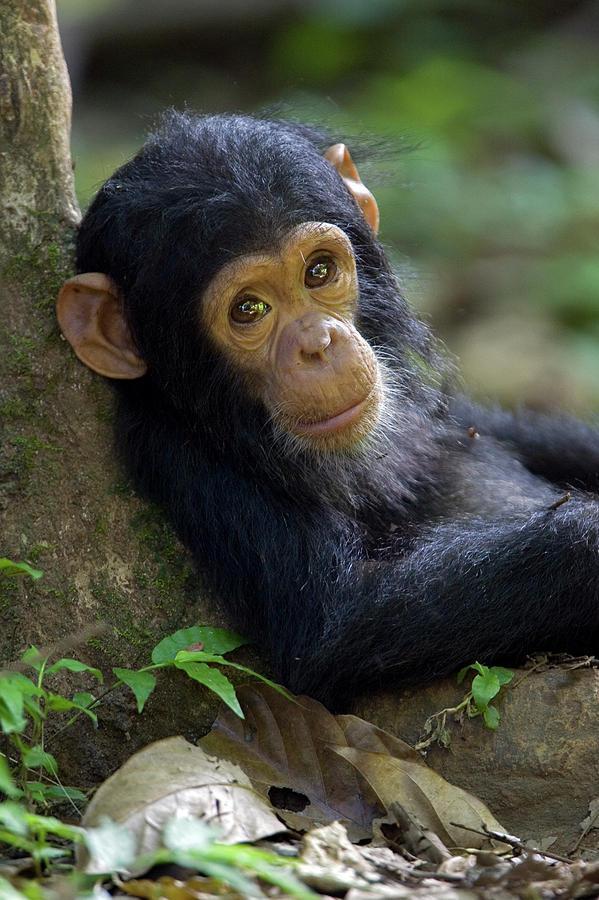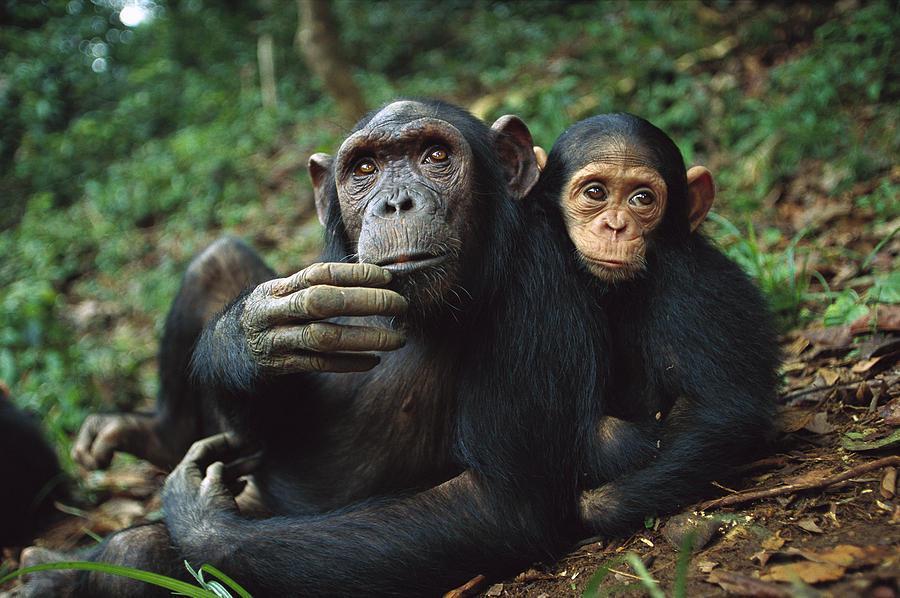The first image is the image on the left, the second image is the image on the right. For the images displayed, is the sentence "there is exactly one animal in the image on the left" factually correct? Answer yes or no. Yes. The first image is the image on the left, the second image is the image on the right. For the images displayed, is the sentence "An image shows one adult chimp next to a baby chimp, with both faces visible." factually correct? Answer yes or no. Yes. 